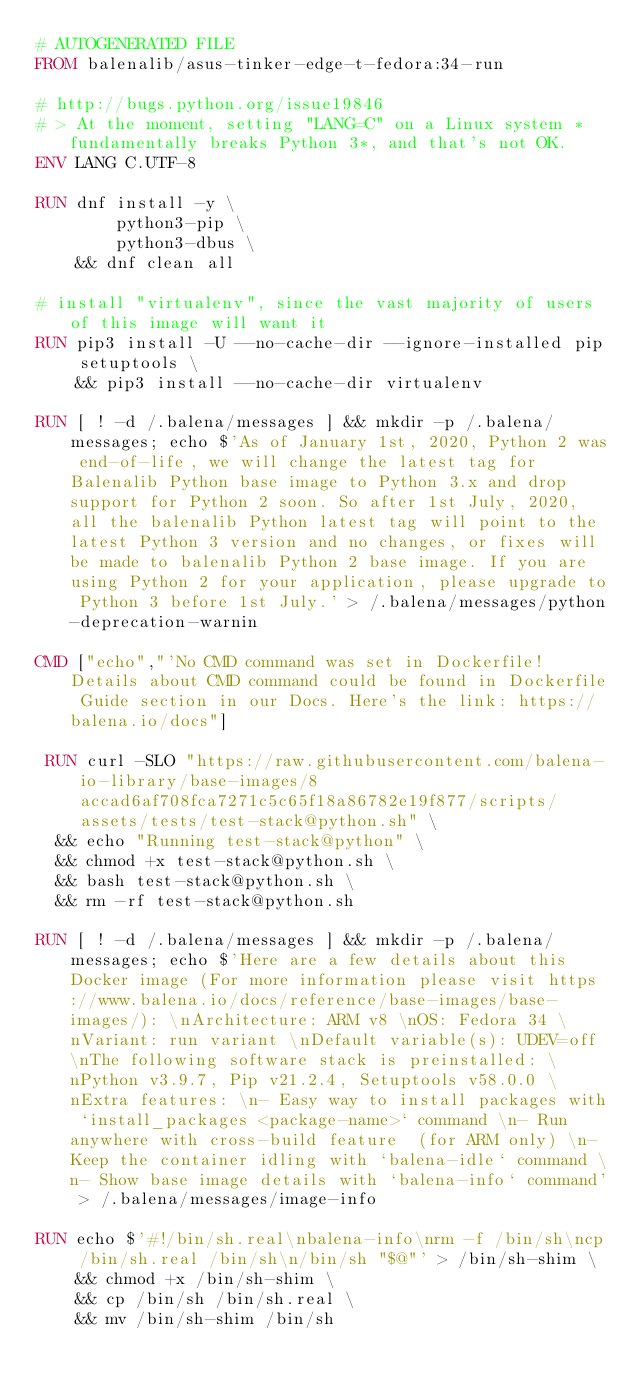Convert code to text. <code><loc_0><loc_0><loc_500><loc_500><_Dockerfile_># AUTOGENERATED FILE
FROM balenalib/asus-tinker-edge-t-fedora:34-run

# http://bugs.python.org/issue19846
# > At the moment, setting "LANG=C" on a Linux system *fundamentally breaks Python 3*, and that's not OK.
ENV LANG C.UTF-8

RUN dnf install -y \
		python3-pip \
		python3-dbus \
	&& dnf clean all

# install "virtualenv", since the vast majority of users of this image will want it
RUN pip3 install -U --no-cache-dir --ignore-installed pip setuptools \
	&& pip3 install --no-cache-dir virtualenv

RUN [ ! -d /.balena/messages ] && mkdir -p /.balena/messages; echo $'As of January 1st, 2020, Python 2 was end-of-life, we will change the latest tag for Balenalib Python base image to Python 3.x and drop support for Python 2 soon. So after 1st July, 2020, all the balenalib Python latest tag will point to the latest Python 3 version and no changes, or fixes will be made to balenalib Python 2 base image. If you are using Python 2 for your application, please upgrade to Python 3 before 1st July.' > /.balena/messages/python-deprecation-warnin

CMD ["echo","'No CMD command was set in Dockerfile! Details about CMD command could be found in Dockerfile Guide section in our Docs. Here's the link: https://balena.io/docs"]

 RUN curl -SLO "https://raw.githubusercontent.com/balena-io-library/base-images/8accad6af708fca7271c5c65f18a86782e19f877/scripts/assets/tests/test-stack@python.sh" \
  && echo "Running test-stack@python" \
  && chmod +x test-stack@python.sh \
  && bash test-stack@python.sh \
  && rm -rf test-stack@python.sh 

RUN [ ! -d /.balena/messages ] && mkdir -p /.balena/messages; echo $'Here are a few details about this Docker image (For more information please visit https://www.balena.io/docs/reference/base-images/base-images/): \nArchitecture: ARM v8 \nOS: Fedora 34 \nVariant: run variant \nDefault variable(s): UDEV=off \nThe following software stack is preinstalled: \nPython v3.9.7, Pip v21.2.4, Setuptools v58.0.0 \nExtra features: \n- Easy way to install packages with `install_packages <package-name>` command \n- Run anywhere with cross-build feature  (for ARM only) \n- Keep the container idling with `balena-idle` command \n- Show base image details with `balena-info` command' > /.balena/messages/image-info

RUN echo $'#!/bin/sh.real\nbalena-info\nrm -f /bin/sh\ncp /bin/sh.real /bin/sh\n/bin/sh "$@"' > /bin/sh-shim \
	&& chmod +x /bin/sh-shim \
	&& cp /bin/sh /bin/sh.real \
	&& mv /bin/sh-shim /bin/sh</code> 